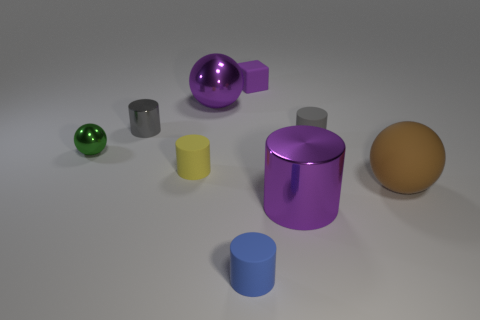Does the blue object have the same shape as the large brown rubber thing?
Offer a very short reply. No. What number of big shiny objects have the same shape as the big matte thing?
Your response must be concise. 1. There is a large metal cylinder; how many large metallic objects are to the left of it?
Make the answer very short. 1. Is the color of the big thing that is on the left side of the blue matte cylinder the same as the large metal cylinder?
Provide a succinct answer. Yes. What number of purple metal cylinders have the same size as the rubber ball?
Make the answer very short. 1. The purple thing that is made of the same material as the purple cylinder is what shape?
Your response must be concise. Sphere. Are there any large spheres of the same color as the tiny matte block?
Provide a succinct answer. Yes. What is the big purple cylinder made of?
Ensure brevity in your answer.  Metal. How many things are blue shiny blocks or large metal things?
Ensure brevity in your answer.  2. What size is the metal object that is on the right side of the large purple ball?
Offer a very short reply. Large. 